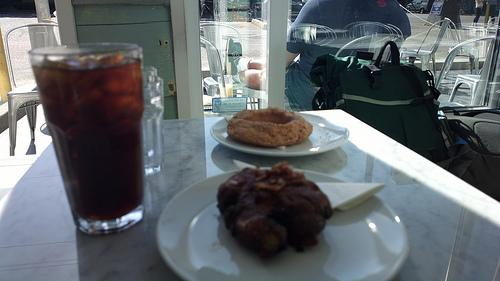List all the objects present in the image. Plates, pastry, clear glass, brown liquid, white chair, white and grey table, green bag, black straps, soda, small empty glass, green siding, round plate, metal chair, person sitting outside, hole in paint, reflection, marble counter, drink, circular food, dark brown food, white napkin, part of counter, ice cubes, light on plate, donut, a table, food on plate, clear glass on table, ice in glass, dark brown carbonated beverage, white circled ceramic snack plate, triangular folded white napkin, brown sugary cookie snack, light brown sugary snack, white granite table top, man in blue shirt, green travel bag, empty clear glass, green section of wall. What kind of snacks can be found on the plates in the image? There are light and dark brown pastries, circular food, and a brown sugary cookie snack on the plates. Create a short poem or verse about the table, incorporating the table's color scheme and the pastries. Upon the white and grey expanse, Whether the glass on the table is empty or filled, and if filled, with what? The glass on the table is filled with a brown carbonated beverage. Is the person sitting outside the window wearing a pink shirt? The image has a mention of a man in a blue shirt outside the window, but there is no information about someone wearing a pink shirt. In terms of shape, how would you describe the plates on the table? The plates are round. Identify if there is any external element outside the window. Yes, there is a person sitting outside the window. Which of the following options correctly describes the bag? (1) Green bag with black straps (2) Red bag with yellow straps (3) Blue bag with white straps (4) Black bag with pink straps Green bag with black straps Give a stylish description for the image focusing on the table setting. A beautifully set table adorned with white round plates hosts an assortment of savory pastries and delights, illuminated by soft light, enticing one to indulge. Describe the cookie in terms of color and taste. The cookie is brown, and it is likely sugary. What material is used for the table's surface? The table has a white marble counter top. Are there any yellow ice cubes in the glass of brown liquid? The image information states that there are ice cubes in the glass, but it doesn't mention yellow ice cubes, just regular ones. Is there a red chair next to the table? The image contains information about a white and a metal chair, but there is no mention of a red chair. What is unique about the wall's color behind the table? There is a green siding on the wall. What is the color of the plates on the table? White What object is leaning against the glass and what color is it? A green bag with black straps is leaning against the glass. Express the person's activity outside the window. The person outside the window is sitting down. Is there a purple bag near the glass? The image contains information about a green bag with black straps, but there is no mention of a purple bag. Provide a short narrative of the scene from the perspective of the person sitting outside the window. As I sat outside, glimpsing through the window, I couldn't help but notice the table adorned with round white plates, delicious pastries, and a glass of cool, inviting beverage. The green bag leaning against the glass caught my eye, as it seemed out of place in this cozy setting. Describe the food on the plate. There is a light brown pastry and a separate dark brown pastry on the white round plate. What specific pastry is also shown on the round plate? A donut. What type of liquid is likely in the clear glass and what is added to it for maintaining temperature? The clear glass is likely filled with brown carbonated beverage, and ice cubes are added to make the drink cold. Does the white plate on the table have a square shape? The image mentions white and round plates but does not reference any square plates. Is the pastry on the table blue? The image contains information about light brown and dark brown pastries, but there is no information about a blue pastry. Please provide a brief overview of the scene. The scene features a table with white round plates, pastries, a glass filled with brown liquid, and a white folded napkin. There is a green bag, a white chair, and a person sitting outside the window. What is the folded white object on the table used for? The folded white object is a napkin. Mention the action of the light on the plate. There is a reflection of light on the plate. 